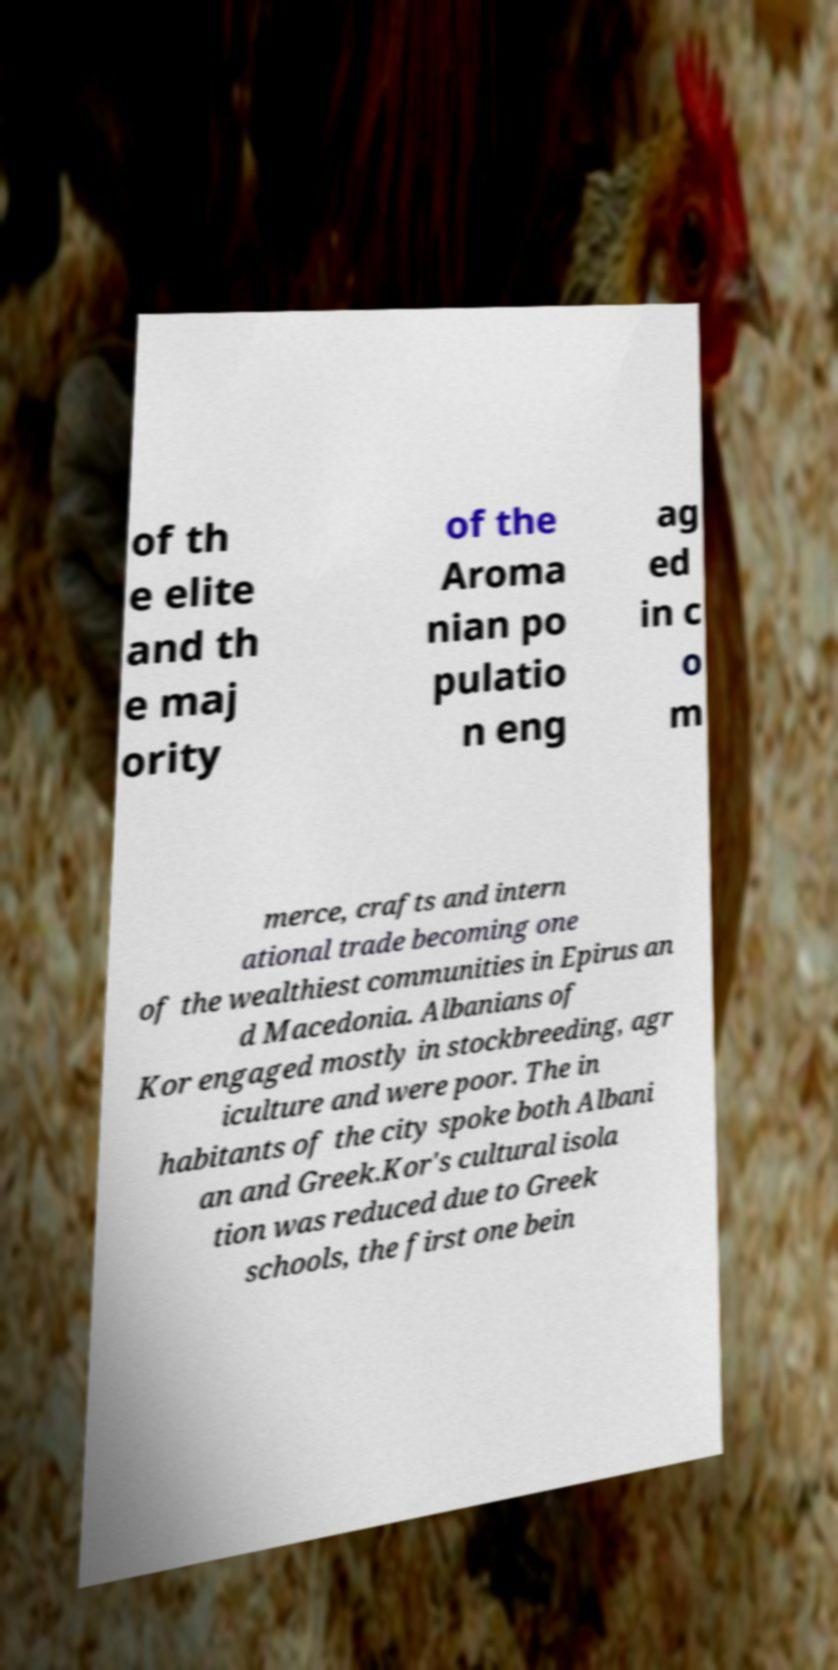I need the written content from this picture converted into text. Can you do that? of th e elite and th e maj ority of the Aroma nian po pulatio n eng ag ed in c o m merce, crafts and intern ational trade becoming one of the wealthiest communities in Epirus an d Macedonia. Albanians of Kor engaged mostly in stockbreeding, agr iculture and were poor. The in habitants of the city spoke both Albani an and Greek.Kor's cultural isola tion was reduced due to Greek schools, the first one bein 